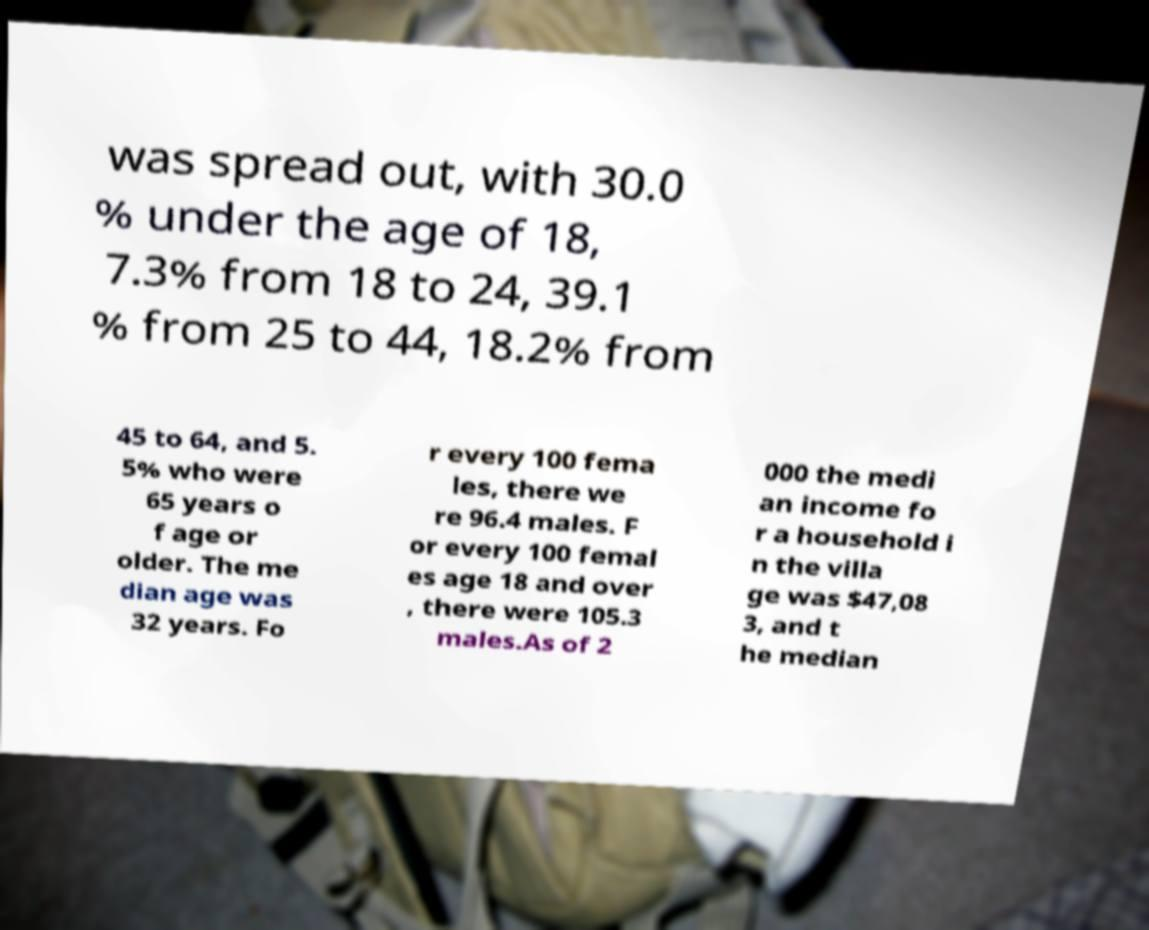What messages or text are displayed in this image? I need them in a readable, typed format. was spread out, with 30.0 % under the age of 18, 7.3% from 18 to 24, 39.1 % from 25 to 44, 18.2% from 45 to 64, and 5. 5% who were 65 years o f age or older. The me dian age was 32 years. Fo r every 100 fema les, there we re 96.4 males. F or every 100 femal es age 18 and over , there were 105.3 males.As of 2 000 the medi an income fo r a household i n the villa ge was $47,08 3, and t he median 